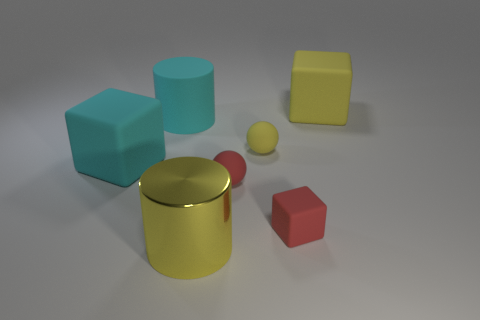Subtract all brown cylinders. Subtract all green cubes. How many cylinders are left? 2 Add 1 red rubber cylinders. How many objects exist? 8 Subtract all spheres. How many objects are left? 5 Add 7 cyan matte blocks. How many cyan matte blocks exist? 8 Subtract 0 gray cubes. How many objects are left? 7 Subtract all small red rubber cubes. Subtract all yellow matte things. How many objects are left? 4 Add 1 shiny cylinders. How many shiny cylinders are left? 2 